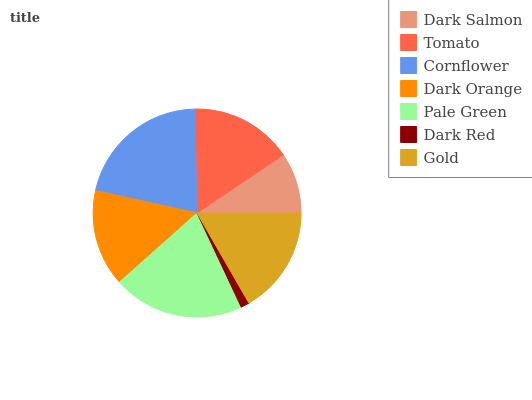Is Dark Red the minimum?
Answer yes or no. Yes. Is Cornflower the maximum?
Answer yes or no. Yes. Is Tomato the minimum?
Answer yes or no. No. Is Tomato the maximum?
Answer yes or no. No. Is Tomato greater than Dark Salmon?
Answer yes or no. Yes. Is Dark Salmon less than Tomato?
Answer yes or no. Yes. Is Dark Salmon greater than Tomato?
Answer yes or no. No. Is Tomato less than Dark Salmon?
Answer yes or no. No. Is Tomato the high median?
Answer yes or no. Yes. Is Tomato the low median?
Answer yes or no. Yes. Is Dark Salmon the high median?
Answer yes or no. No. Is Dark Orange the low median?
Answer yes or no. No. 